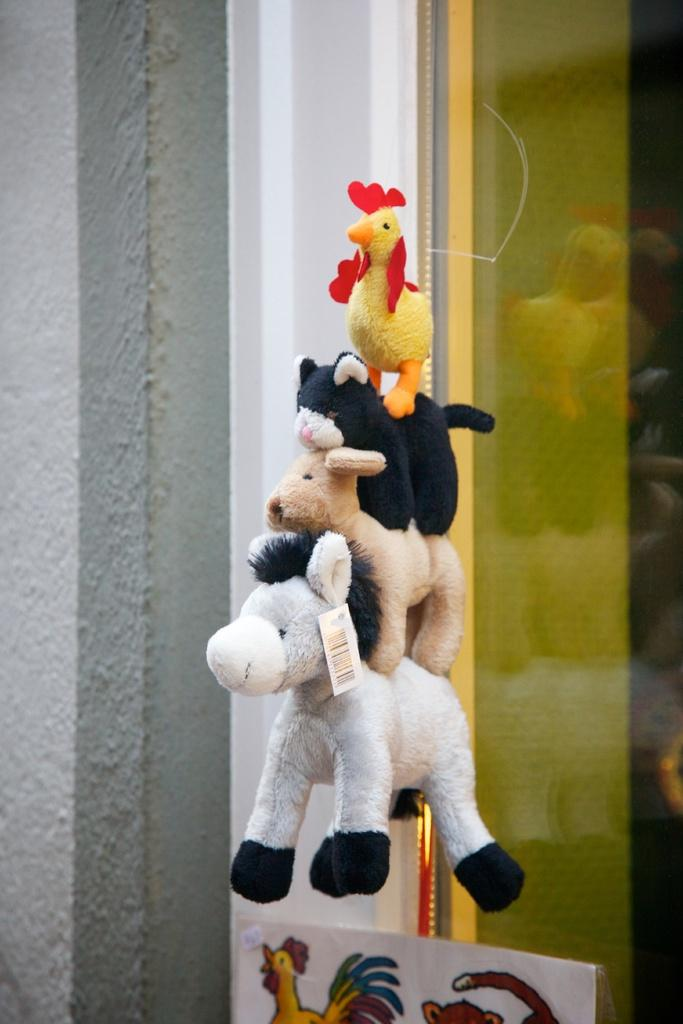What objects are in the foreground of the image? There are toys in the foreground of the image. How are the toys arranged in the image? The toys are arranged one after the other. Where is the drawer located in the image? There is no drawer present in the image. What type of glue is being used to hold the toys together in the image? There is no glue present in the image, and the toys are not attached to each other. 